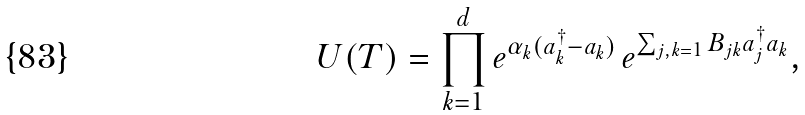Convert formula to latex. <formula><loc_0><loc_0><loc_500><loc_500>U ( T ) = \prod _ { k = 1 } ^ { d } e ^ { \alpha _ { k } ( a _ { k } ^ { \dagger } - a _ { k } ) } \, e ^ { \sum _ { j , k = 1 } B _ { j k } a _ { j } ^ { \dagger } a _ { k } } ,</formula> 